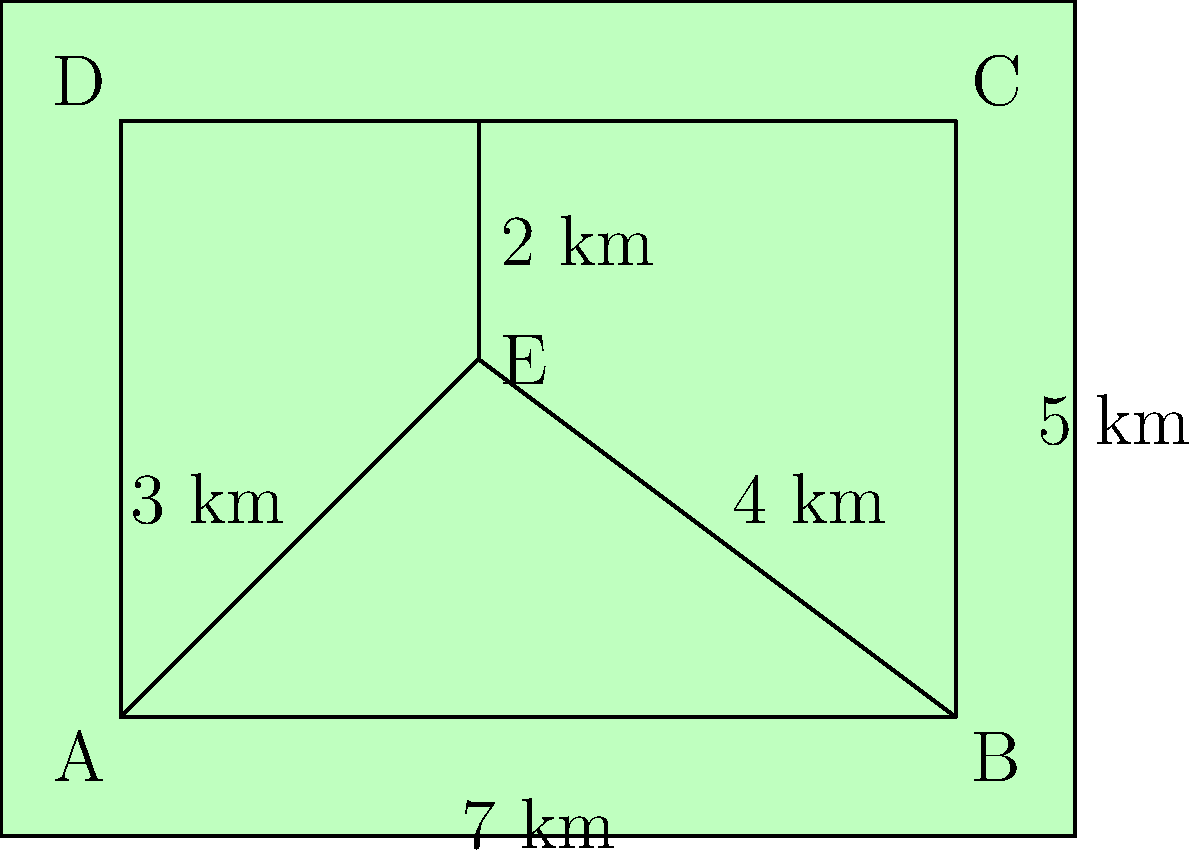As an environmental science teacher, you're planning a field trip to a newly established nature reserve. The reserve has an irregular shape, as shown in the diagram. To calculate the area that students can explore, you decide to decompose the shape into simpler geometric figures. Given that AB = 7 km, BC = 5 km, and DE = 2 km, determine the total area of the nature reserve in square kilometers. Let's approach this step-by-step:

1) We can decompose the shape into a rectangle (ABCD) and two triangles (AEB and EDC).

2) For the rectangle ABCD:
   Area = length × width
   Area = 7 km × 5 km = 35 km²

3) For triangle AEB:
   Base (AB) = 7 km
   Height (DE) = 2 km
   Area = $\frac{1}{2}$ × base × height
   Area = $\frac{1}{2}$ × 7 km × 2 km = 7 km²

4) For triangle EDC:
   We need to find the base (EC)
   EC = BC - BE = 5 km - 3 km = 2 km
   Height (DE) = 2 km
   Area = $\frac{1}{2}$ × base × height
   Area = $\frac{1}{2}$ × 2 km × 2 km = 2 km²

5) Total area of the nature reserve:
   Total Area = Area of rectangle + Area of triangle AEB + Area of triangle EDC
   Total Area = 35 km² + 7 km² + 2 km² = 44 km²

Therefore, the total area of the nature reserve is 44 square kilometers.
Answer: 44 km² 